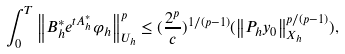<formula> <loc_0><loc_0><loc_500><loc_500>\int _ { 0 } ^ { T } { \left \| { B ^ { * } _ { h } e ^ { t A ^ { * } _ { h } } \varphi _ { h } } \right \| ^ { p } _ { U _ { h } } } \leq ( \frac { 2 ^ { p } } { c } ) ^ { 1 / { ( p - 1 ) } } ( \left \| { P _ { h } y _ { 0 } } \right \| _ { X _ { h } } ^ { p / { ( p - 1 ) } } ) ,</formula> 